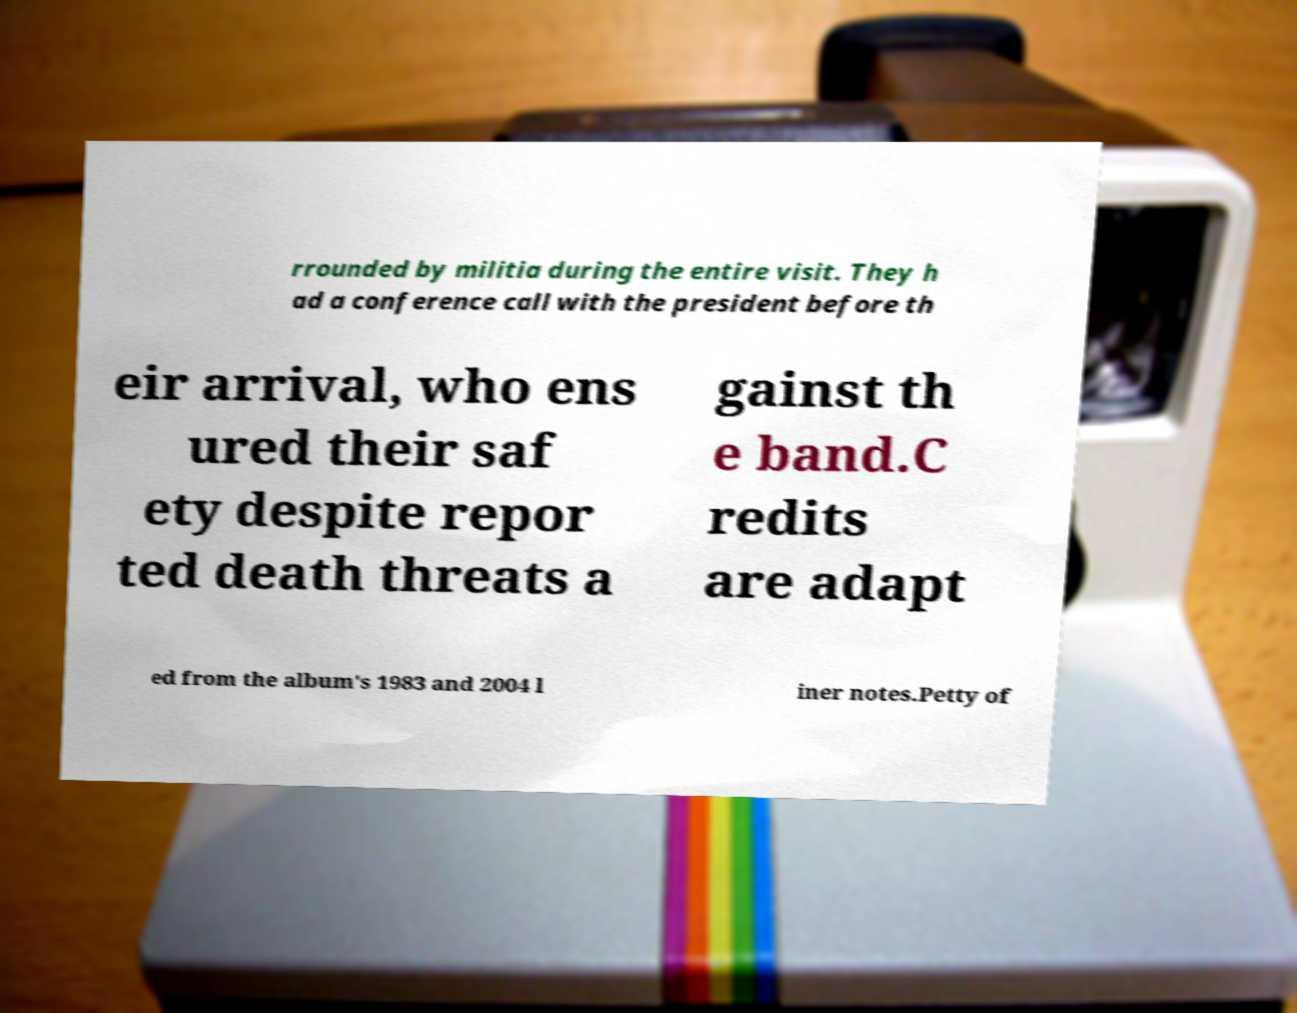Please read and relay the text visible in this image. What does it say? rrounded by militia during the entire visit. They h ad a conference call with the president before th eir arrival, who ens ured their saf ety despite repor ted death threats a gainst th e band.C redits are adapt ed from the album's 1983 and 2004 l iner notes.Petty of 